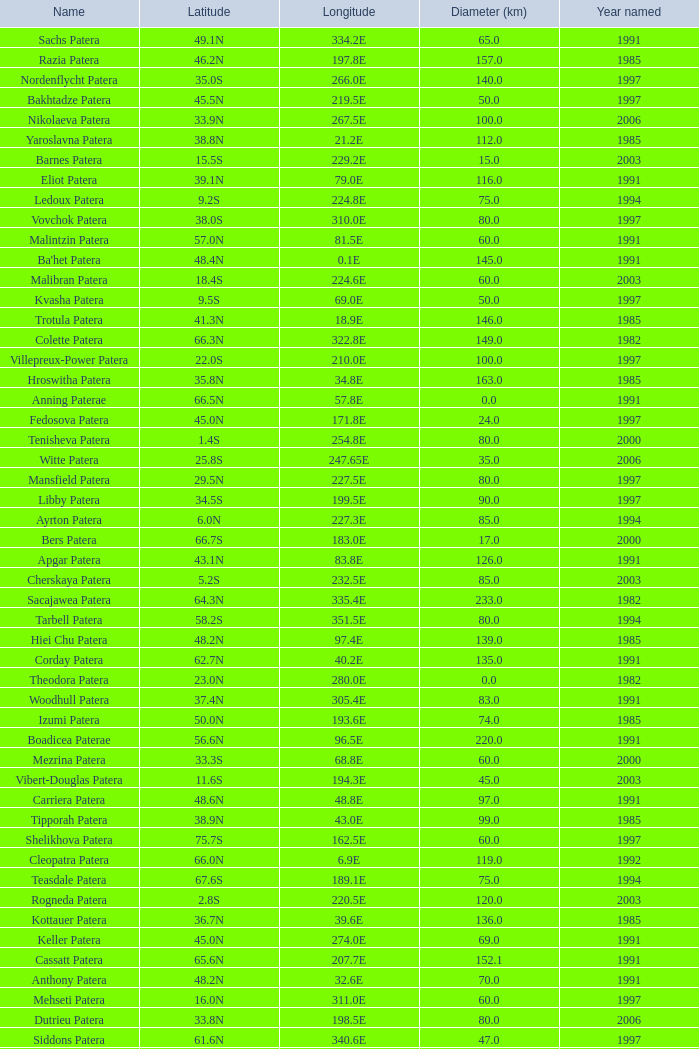What is the average Year Named, when Latitude is 37.9N, and when Diameter (km) is greater than 76? None. 